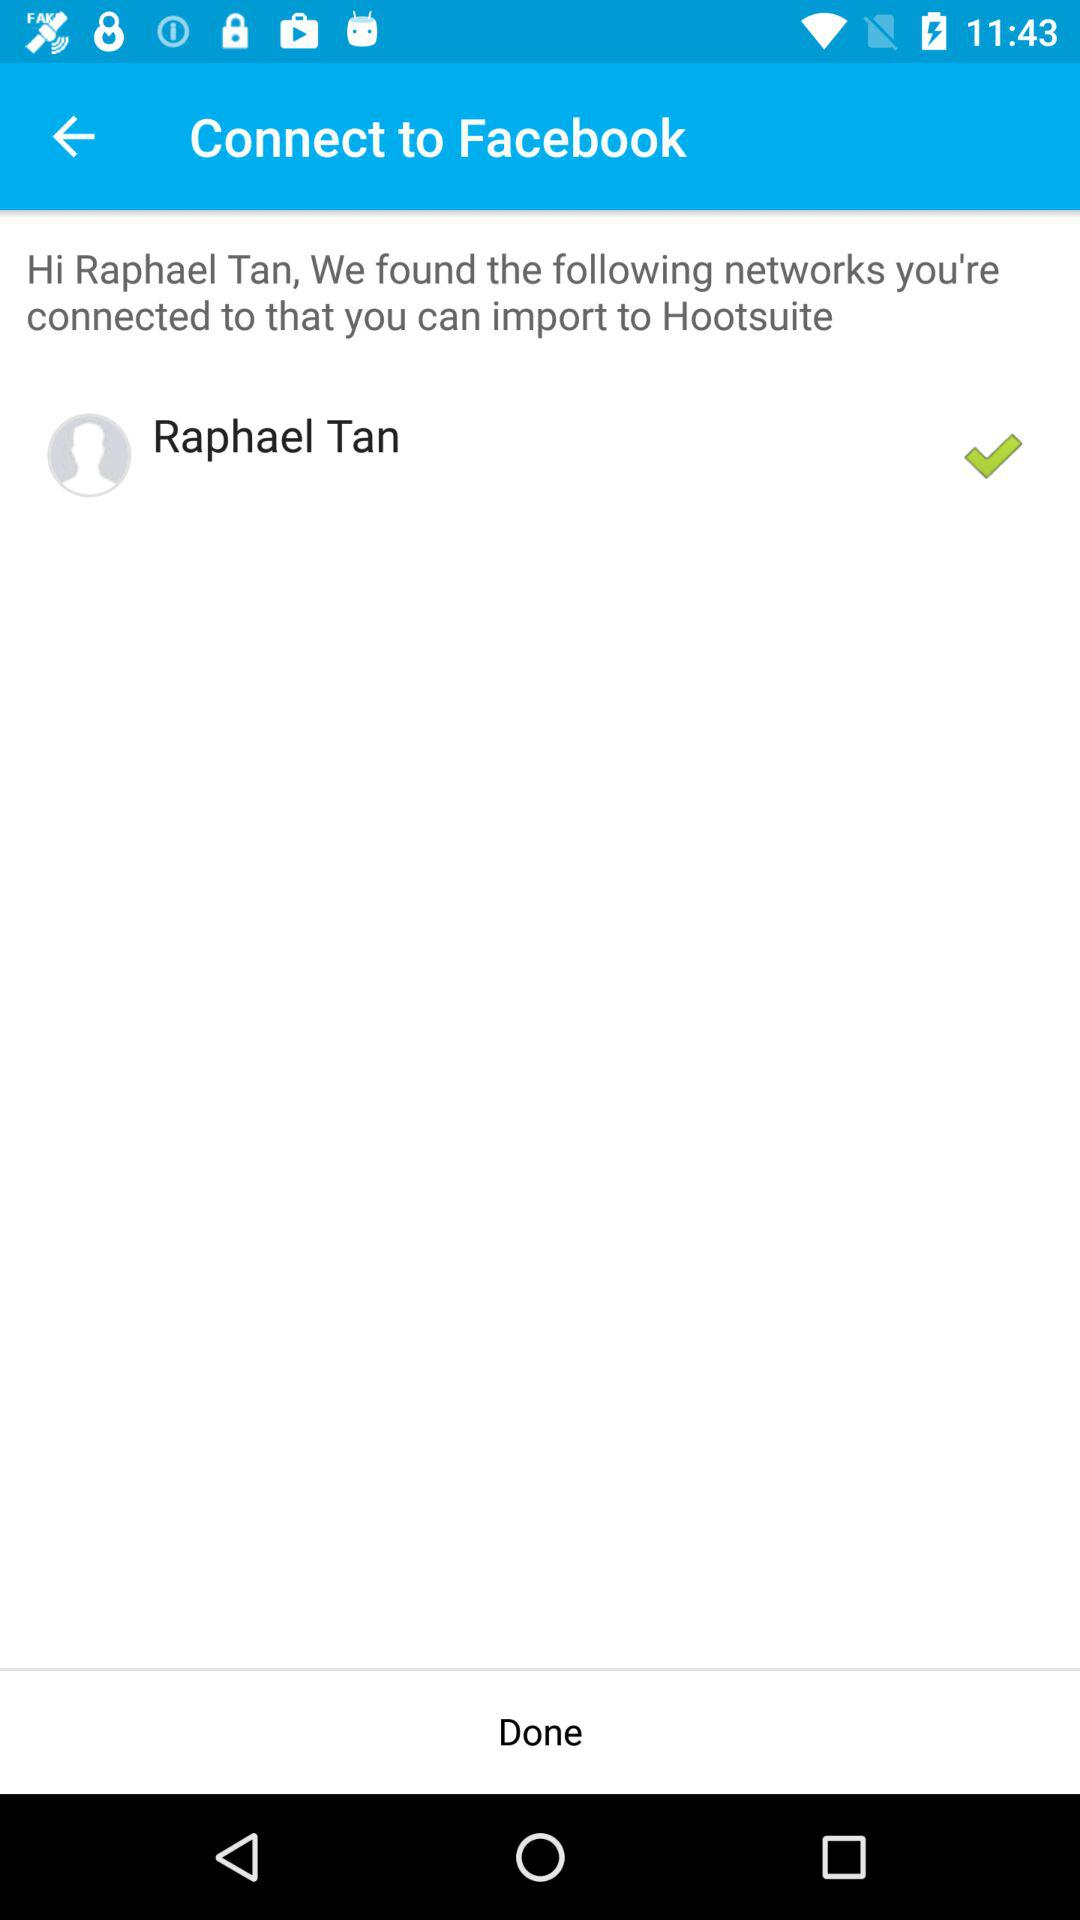What application are we accessing? The application you are accessing is "Hootsuite". 